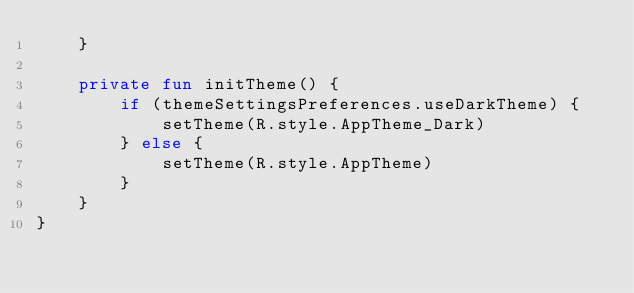Convert code to text. <code><loc_0><loc_0><loc_500><loc_500><_Kotlin_>    }

    private fun initTheme() {
        if (themeSettingsPreferences.useDarkTheme) {
            setTheme(R.style.AppTheme_Dark)
        } else {
            setTheme(R.style.AppTheme)
        }
    }
}</code> 